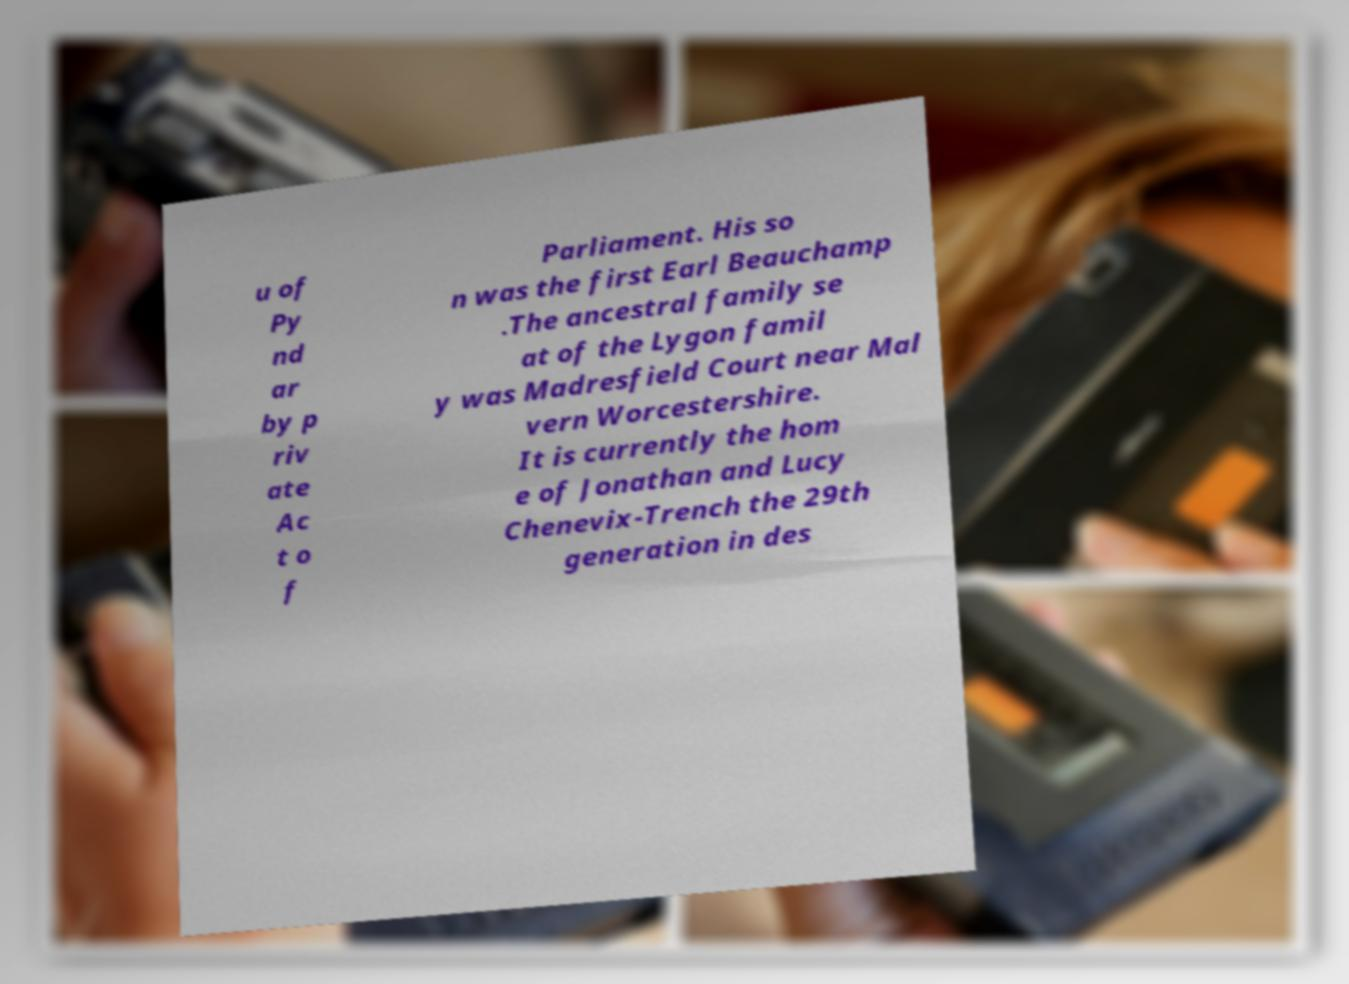There's text embedded in this image that I need extracted. Can you transcribe it verbatim? u of Py nd ar by p riv ate Ac t o f Parliament. His so n was the first Earl Beauchamp .The ancestral family se at of the Lygon famil y was Madresfield Court near Mal vern Worcestershire. It is currently the hom e of Jonathan and Lucy Chenevix-Trench the 29th generation in des 